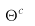Convert formula to latex. <formula><loc_0><loc_0><loc_500><loc_500>\Theta ^ { c _ { v } }</formula> 